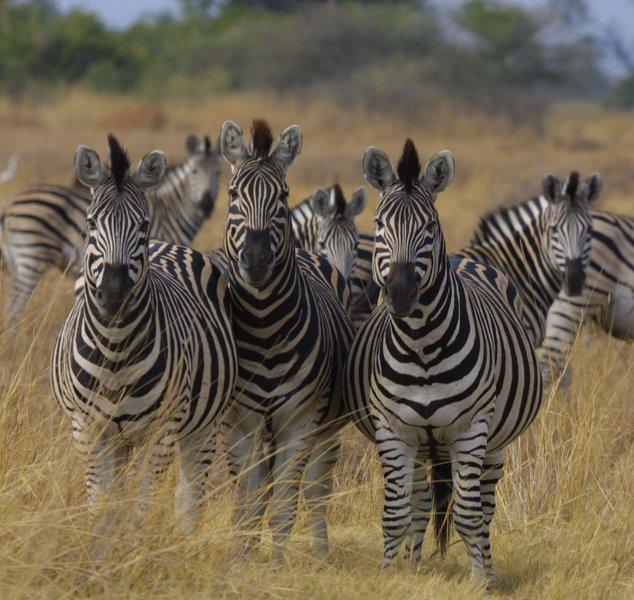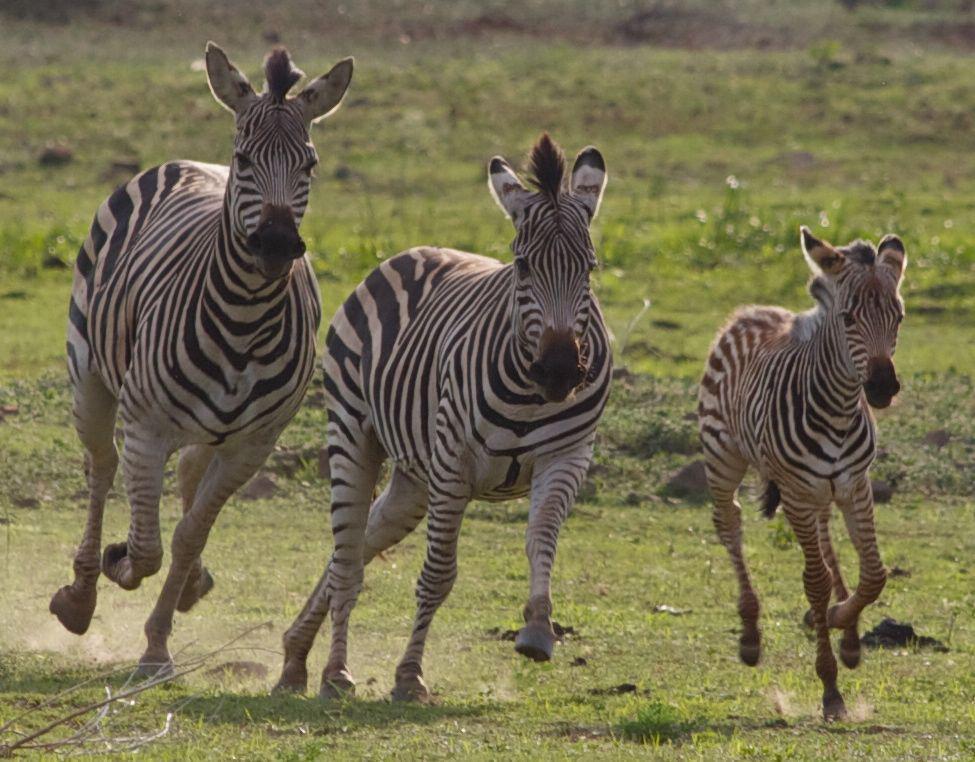The first image is the image on the left, the second image is the image on the right. Examine the images to the left and right. Is the description "The combined images include zebra at a watering hole and a rear-facing elephant near a standing zebra." accurate? Answer yes or no. No. The first image is the image on the left, the second image is the image on the right. Considering the images on both sides, is "Zebras are running." valid? Answer yes or no. Yes. 